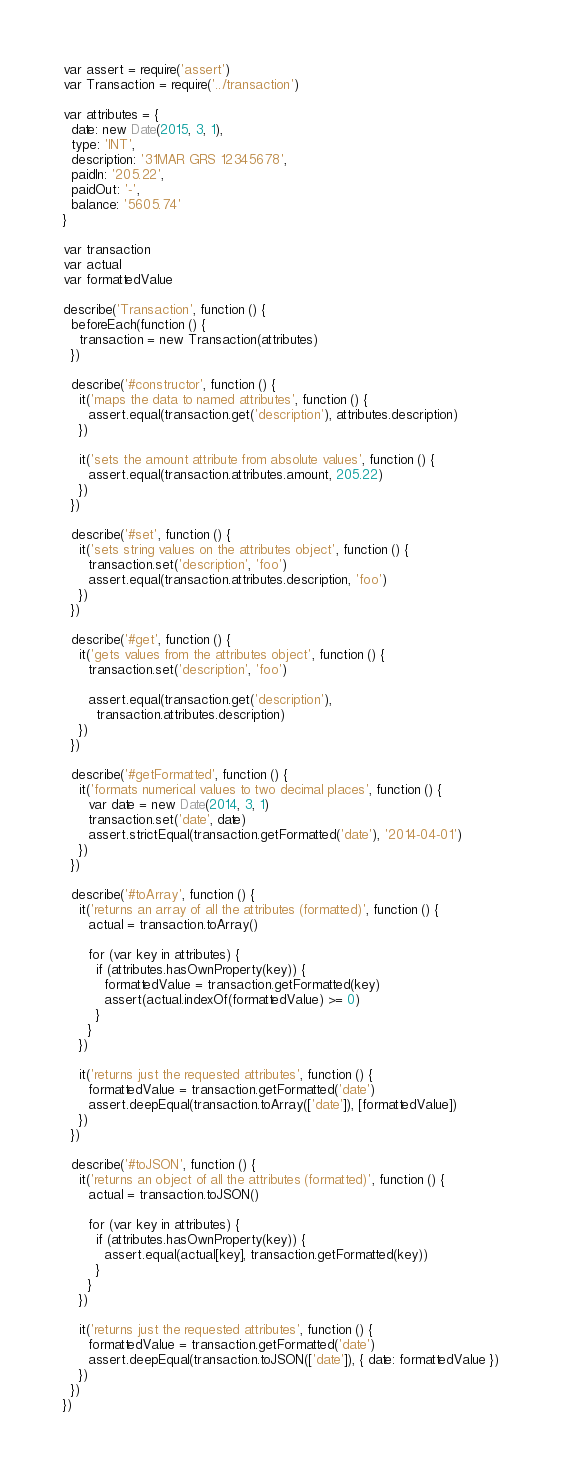<code> <loc_0><loc_0><loc_500><loc_500><_JavaScript_>var assert = require('assert')
var Transaction = require('../transaction')

var attributes = {
  date: new Date(2015, 3, 1),
  type: 'INT',
  description: '31MAR GRS 12345678',
  paidIn: '205.22',
  paidOut: '-',
  balance: '5605.74'
}

var transaction
var actual
var formattedValue

describe('Transaction', function () {
  beforeEach(function () {
    transaction = new Transaction(attributes)
  })

  describe('#constructor', function () {
    it('maps the data to named attributes', function () {
      assert.equal(transaction.get('description'), attributes.description)
    })

    it('sets the amount attribute from absolute values', function () {
      assert.equal(transaction.attributes.amount, 205.22)
    })
  })

  describe('#set', function () {
    it('sets string values on the attributes object', function () {
      transaction.set('description', 'foo')
      assert.equal(transaction.attributes.description, 'foo')
    })
  })

  describe('#get', function () {
    it('gets values from the attributes object', function () {
      transaction.set('description', 'foo')

      assert.equal(transaction.get('description'),
        transaction.attributes.description)
    })
  })

  describe('#getFormatted', function () {
    it('formats numerical values to two decimal places', function () {
      var date = new Date(2014, 3, 1)
      transaction.set('date', date)
      assert.strictEqual(transaction.getFormatted('date'), '2014-04-01')
    })
  })

  describe('#toArray', function () {
    it('returns an array of all the attributes (formatted)', function () {
      actual = transaction.toArray()

      for (var key in attributes) {
        if (attributes.hasOwnProperty(key)) {
          formattedValue = transaction.getFormatted(key)
          assert(actual.indexOf(formattedValue) >= 0)
        }
      }
    })

    it('returns just the requested attributes', function () {
      formattedValue = transaction.getFormatted('date')
      assert.deepEqual(transaction.toArray(['date']), [formattedValue])
    })
  })

  describe('#toJSON', function () {
    it('returns an object of all the attributes (formatted)', function () {
      actual = transaction.toJSON()

      for (var key in attributes) {
        if (attributes.hasOwnProperty(key)) {
          assert.equal(actual[key], transaction.getFormatted(key))
        }
      }
    })

    it('returns just the requested attributes', function () {
      formattedValue = transaction.getFormatted('date')
      assert.deepEqual(transaction.toJSON(['date']), { date: formattedValue })
    })
  })
})
</code> 